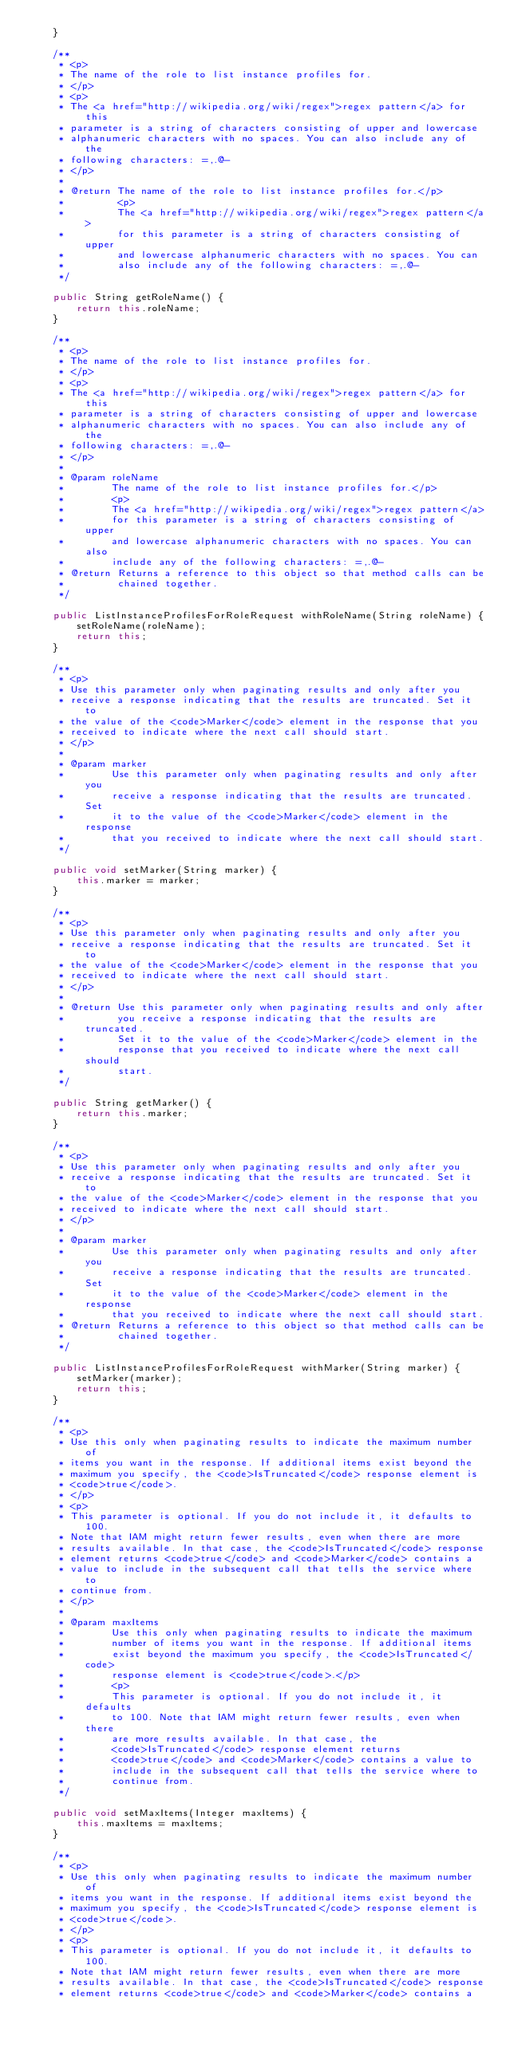<code> <loc_0><loc_0><loc_500><loc_500><_Java_>    }

    /**
     * <p>
     * The name of the role to list instance profiles for.
     * </p>
     * <p>
     * The <a href="http://wikipedia.org/wiki/regex">regex pattern</a> for this
     * parameter is a string of characters consisting of upper and lowercase
     * alphanumeric characters with no spaces. You can also include any of the
     * following characters: =,.@-
     * </p>
     * 
     * @return The name of the role to list instance profiles for.</p>
     *         <p>
     *         The <a href="http://wikipedia.org/wiki/regex">regex pattern</a>
     *         for this parameter is a string of characters consisting of upper
     *         and lowercase alphanumeric characters with no spaces. You can
     *         also include any of the following characters: =,.@-
     */

    public String getRoleName() {
        return this.roleName;
    }

    /**
     * <p>
     * The name of the role to list instance profiles for.
     * </p>
     * <p>
     * The <a href="http://wikipedia.org/wiki/regex">regex pattern</a> for this
     * parameter is a string of characters consisting of upper and lowercase
     * alphanumeric characters with no spaces. You can also include any of the
     * following characters: =,.@-
     * </p>
     * 
     * @param roleName
     *        The name of the role to list instance profiles for.</p>
     *        <p>
     *        The <a href="http://wikipedia.org/wiki/regex">regex pattern</a>
     *        for this parameter is a string of characters consisting of upper
     *        and lowercase alphanumeric characters with no spaces. You can also
     *        include any of the following characters: =,.@-
     * @return Returns a reference to this object so that method calls can be
     *         chained together.
     */

    public ListInstanceProfilesForRoleRequest withRoleName(String roleName) {
        setRoleName(roleName);
        return this;
    }

    /**
     * <p>
     * Use this parameter only when paginating results and only after you
     * receive a response indicating that the results are truncated. Set it to
     * the value of the <code>Marker</code> element in the response that you
     * received to indicate where the next call should start.
     * </p>
     * 
     * @param marker
     *        Use this parameter only when paginating results and only after you
     *        receive a response indicating that the results are truncated. Set
     *        it to the value of the <code>Marker</code> element in the response
     *        that you received to indicate where the next call should start.
     */

    public void setMarker(String marker) {
        this.marker = marker;
    }

    /**
     * <p>
     * Use this parameter only when paginating results and only after you
     * receive a response indicating that the results are truncated. Set it to
     * the value of the <code>Marker</code> element in the response that you
     * received to indicate where the next call should start.
     * </p>
     * 
     * @return Use this parameter only when paginating results and only after
     *         you receive a response indicating that the results are truncated.
     *         Set it to the value of the <code>Marker</code> element in the
     *         response that you received to indicate where the next call should
     *         start.
     */

    public String getMarker() {
        return this.marker;
    }

    /**
     * <p>
     * Use this parameter only when paginating results and only after you
     * receive a response indicating that the results are truncated. Set it to
     * the value of the <code>Marker</code> element in the response that you
     * received to indicate where the next call should start.
     * </p>
     * 
     * @param marker
     *        Use this parameter only when paginating results and only after you
     *        receive a response indicating that the results are truncated. Set
     *        it to the value of the <code>Marker</code> element in the response
     *        that you received to indicate where the next call should start.
     * @return Returns a reference to this object so that method calls can be
     *         chained together.
     */

    public ListInstanceProfilesForRoleRequest withMarker(String marker) {
        setMarker(marker);
        return this;
    }

    /**
     * <p>
     * Use this only when paginating results to indicate the maximum number of
     * items you want in the response. If additional items exist beyond the
     * maximum you specify, the <code>IsTruncated</code> response element is
     * <code>true</code>.
     * </p>
     * <p>
     * This parameter is optional. If you do not include it, it defaults to 100.
     * Note that IAM might return fewer results, even when there are more
     * results available. In that case, the <code>IsTruncated</code> response
     * element returns <code>true</code> and <code>Marker</code> contains a
     * value to include in the subsequent call that tells the service where to
     * continue from.
     * </p>
     * 
     * @param maxItems
     *        Use this only when paginating results to indicate the maximum
     *        number of items you want in the response. If additional items
     *        exist beyond the maximum you specify, the <code>IsTruncated</code>
     *        response element is <code>true</code>.</p>
     *        <p>
     *        This parameter is optional. If you do not include it, it defaults
     *        to 100. Note that IAM might return fewer results, even when there
     *        are more results available. In that case, the
     *        <code>IsTruncated</code> response element returns
     *        <code>true</code> and <code>Marker</code> contains a value to
     *        include in the subsequent call that tells the service where to
     *        continue from.
     */

    public void setMaxItems(Integer maxItems) {
        this.maxItems = maxItems;
    }

    /**
     * <p>
     * Use this only when paginating results to indicate the maximum number of
     * items you want in the response. If additional items exist beyond the
     * maximum you specify, the <code>IsTruncated</code> response element is
     * <code>true</code>.
     * </p>
     * <p>
     * This parameter is optional. If you do not include it, it defaults to 100.
     * Note that IAM might return fewer results, even when there are more
     * results available. In that case, the <code>IsTruncated</code> response
     * element returns <code>true</code> and <code>Marker</code> contains a</code> 